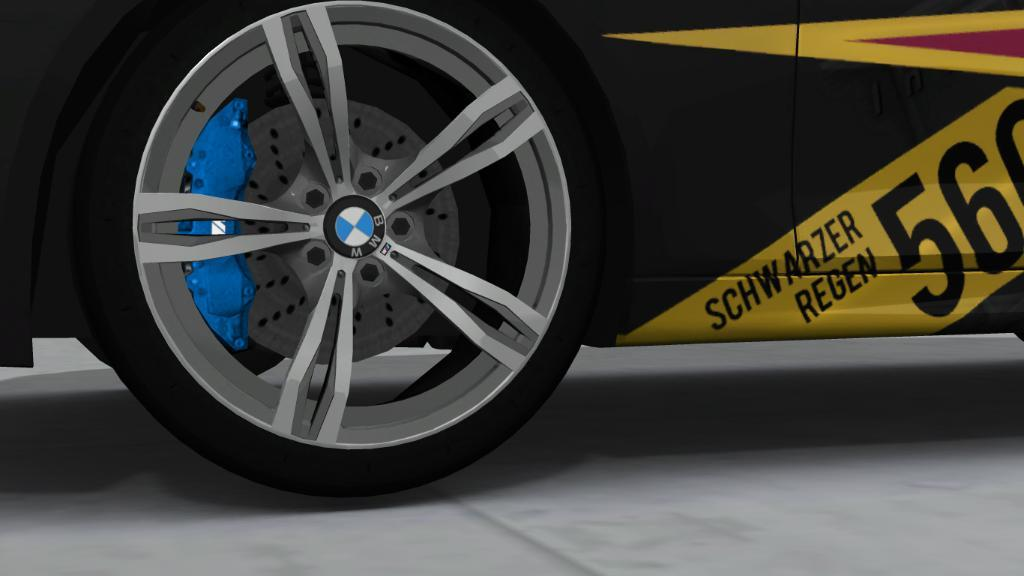What is the main subject of the image? There is a vehicle in the image. What can be seen on the vehicle? There is text written on the vehicle. What is visible at the bottom of the image? The floor is visible at the bottom of the image. How many clover leaves can be seen on the vehicle in the image? There are no clover leaves present on the vehicle in the image. What time of day is it in the image, considering the presence of a ladybug? There is no ladybug present in the image, so it is not possible to determine the time of day based on that information. 